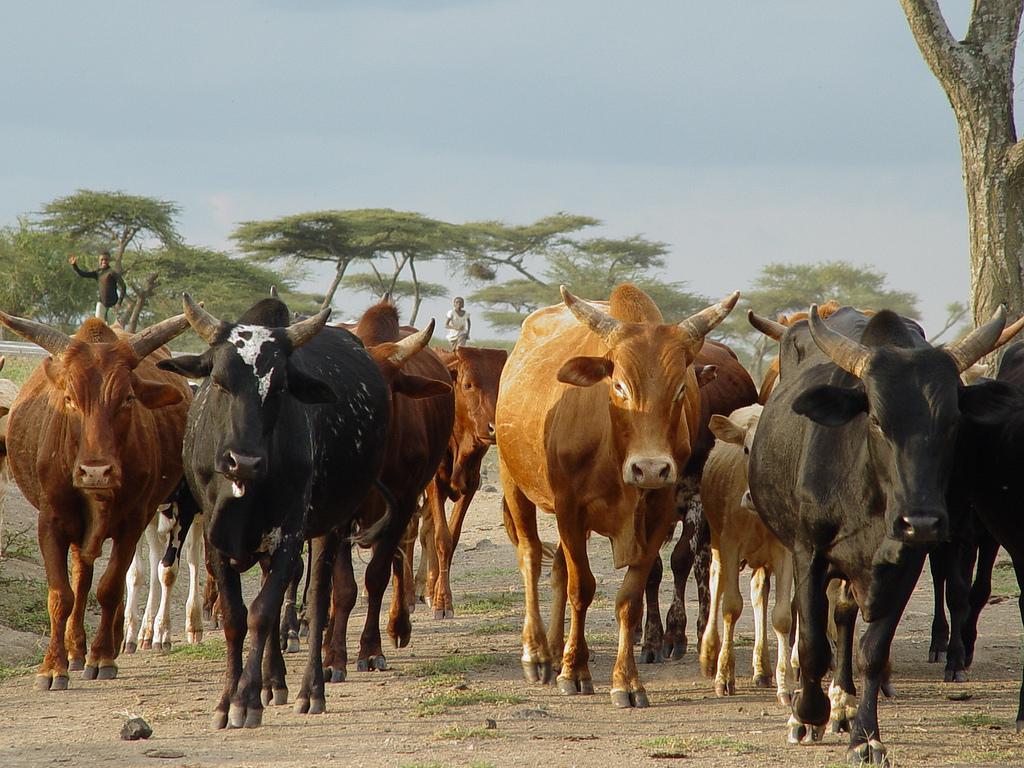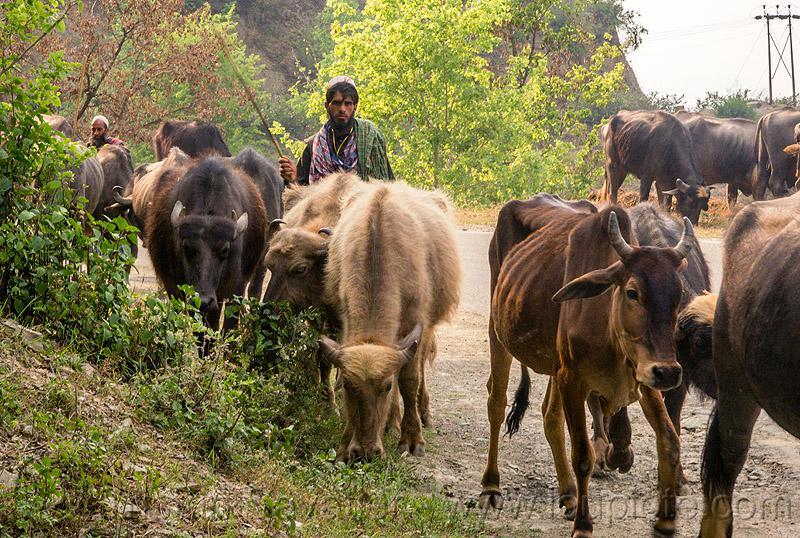The first image is the image on the left, the second image is the image on the right. For the images shown, is this caption "There is a man standing with some cows in the image on the right." true? Answer yes or no. Yes. The first image is the image on the left, the second image is the image on the right. Analyze the images presented: Is the assertion "Each image shows a group of cattle-type animals walking down a path, and the right image shows a man holding a stick walking behind some of them." valid? Answer yes or no. Yes. 